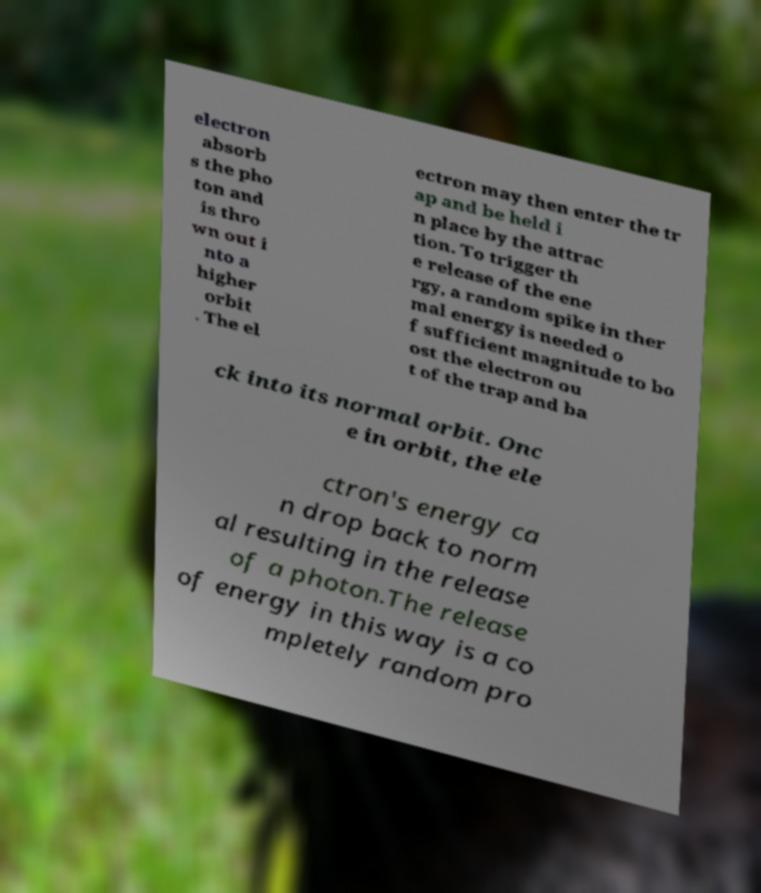Could you assist in decoding the text presented in this image and type it out clearly? electron absorb s the pho ton and is thro wn out i nto a higher orbit . The el ectron may then enter the tr ap and be held i n place by the attrac tion. To trigger th e release of the ene rgy, a random spike in ther mal energy is needed o f sufficient magnitude to bo ost the electron ou t of the trap and ba ck into its normal orbit. Onc e in orbit, the ele ctron's energy ca n drop back to norm al resulting in the release of a photon.The release of energy in this way is a co mpletely random pro 